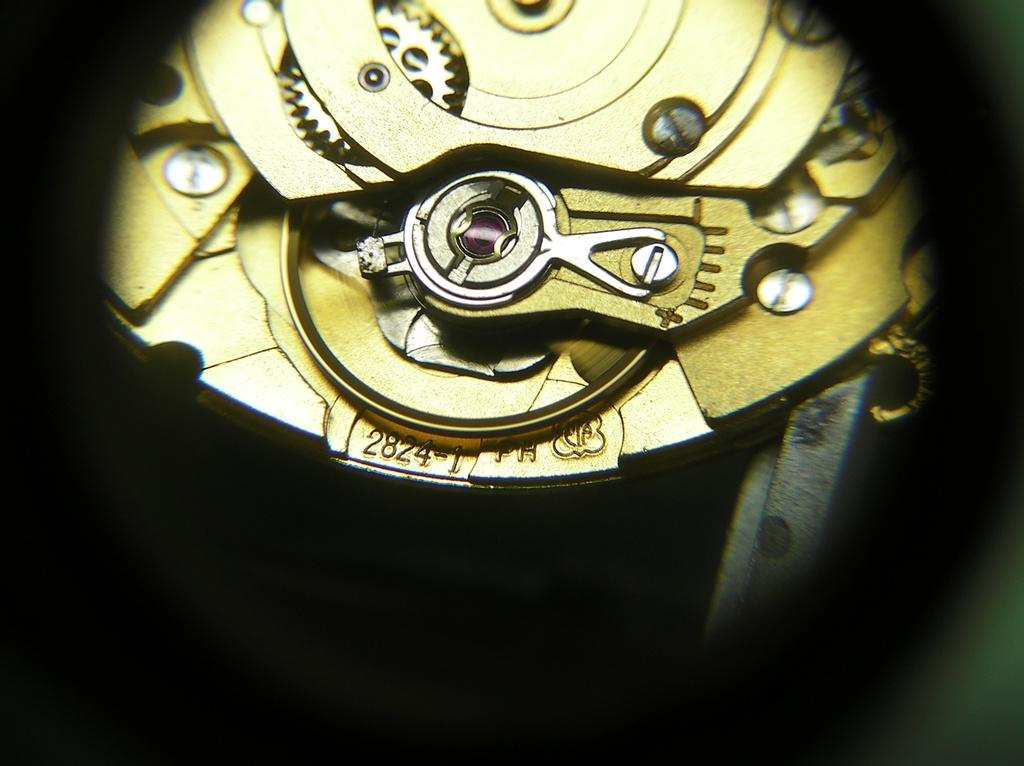<image>
Present a compact description of the photo's key features. The workings of a watch identified as 2824-1. 